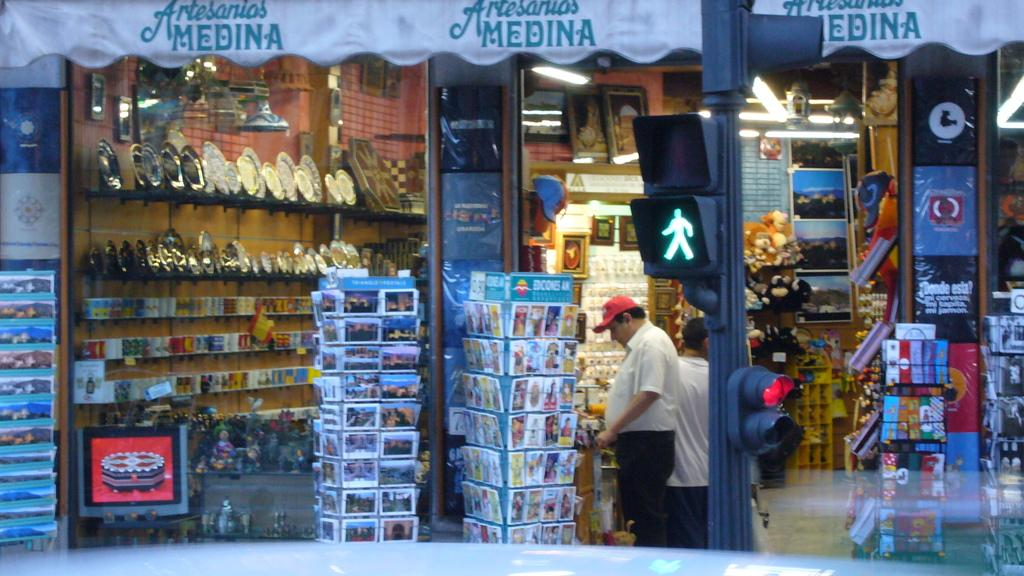<image>
Offer a succinct explanation of the picture presented. Man looking at something by a store named MEDINA. 